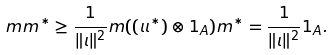<formula> <loc_0><loc_0><loc_500><loc_500>m m ^ { * } \geq \frac { 1 } { \| \iota \| ^ { 2 } } m ( ( \iota \iota ^ { * } ) \otimes 1 _ { A } ) m ^ { * } = \frac { 1 } { \| \iota \| ^ { 2 } } 1 _ { A } .</formula> 